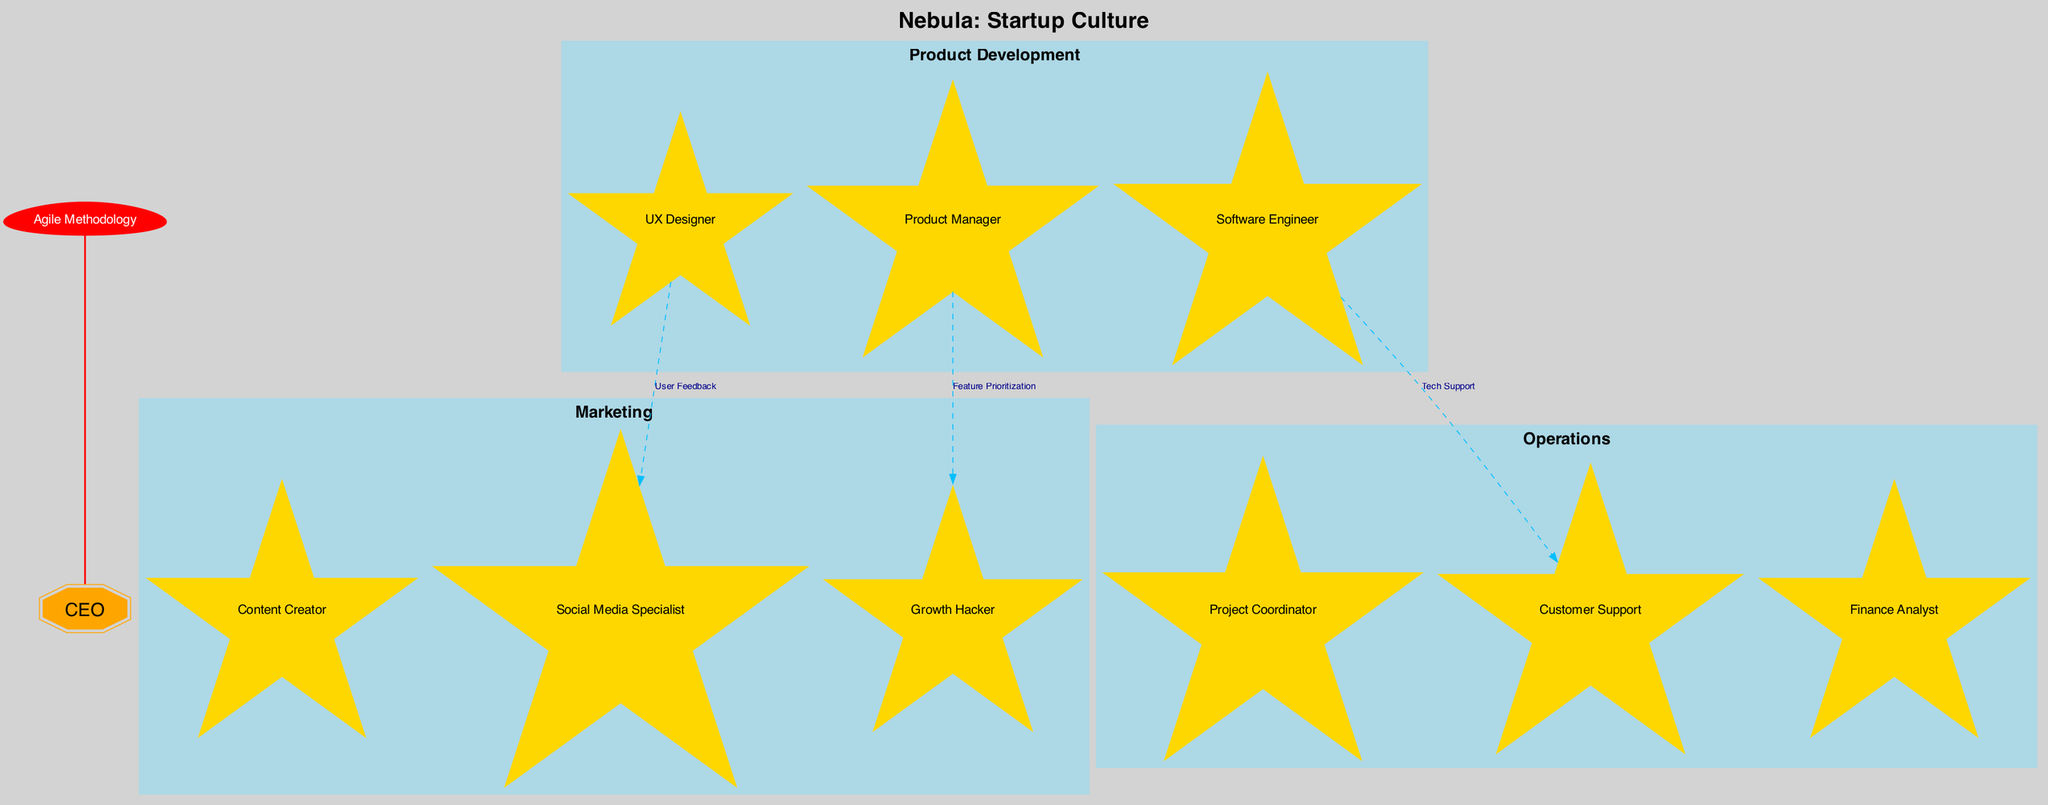What is the central star in this diagram? The central star is labeled "CEO" in the diagram, indicating the leader of the organization.
Answer: CEO How many constellations are shown in the diagram? There are three constellations depicted: "Product Development", "Marketing", and "Operations". Therefore, the total is three.
Answer: 3 Which role is connected to the "Growth Hacker"? The "Product Manager" is connected to the "Growth Hacker", showing a relationship that indicates collaboration on feature prioritization.
Answer: Product Manager What is the label for the connection between the "UX Designer" and "Social Media Specialist"? The diagram indicates that the connection between the "UX Designer" and "Social Media Specialist" is labeled "User Feedback".
Answer: User Feedback Which nebula is represented in the diagram? The diagram represents the nebula as "Startup Culture", symbolizing the environment in which the organization operates.
Answer: Startup Culture How many edges or connections are depicted in the diagram? The diagram illustrates three edges or connections, each connecting different roles and showing their interdependencies.
Answer: 3 What is the role under the "Marketing" constellation? The diagram includes "Content Creator", "Social Media Specialist", and "Growth Hacker" as roles under the "Marketing" constellation.
Answer: Content Creator, Social Media Specialist, Growth Hacker Describe the relationship indicated by the "comet" in the diagram. The "comet" labeled "Agile Methodology" has a bold, undirected connection to the central star (CEO), indicating that agile practices pervade the leadership structure and organizational culture.
Answer: Agile Methodology Who does the "Software Engineer" provide tech support to? According to the diagram, the "Software Engineer" provides tech support to "Customer Support", illustrating cross-functional assistance.
Answer: Customer Support 